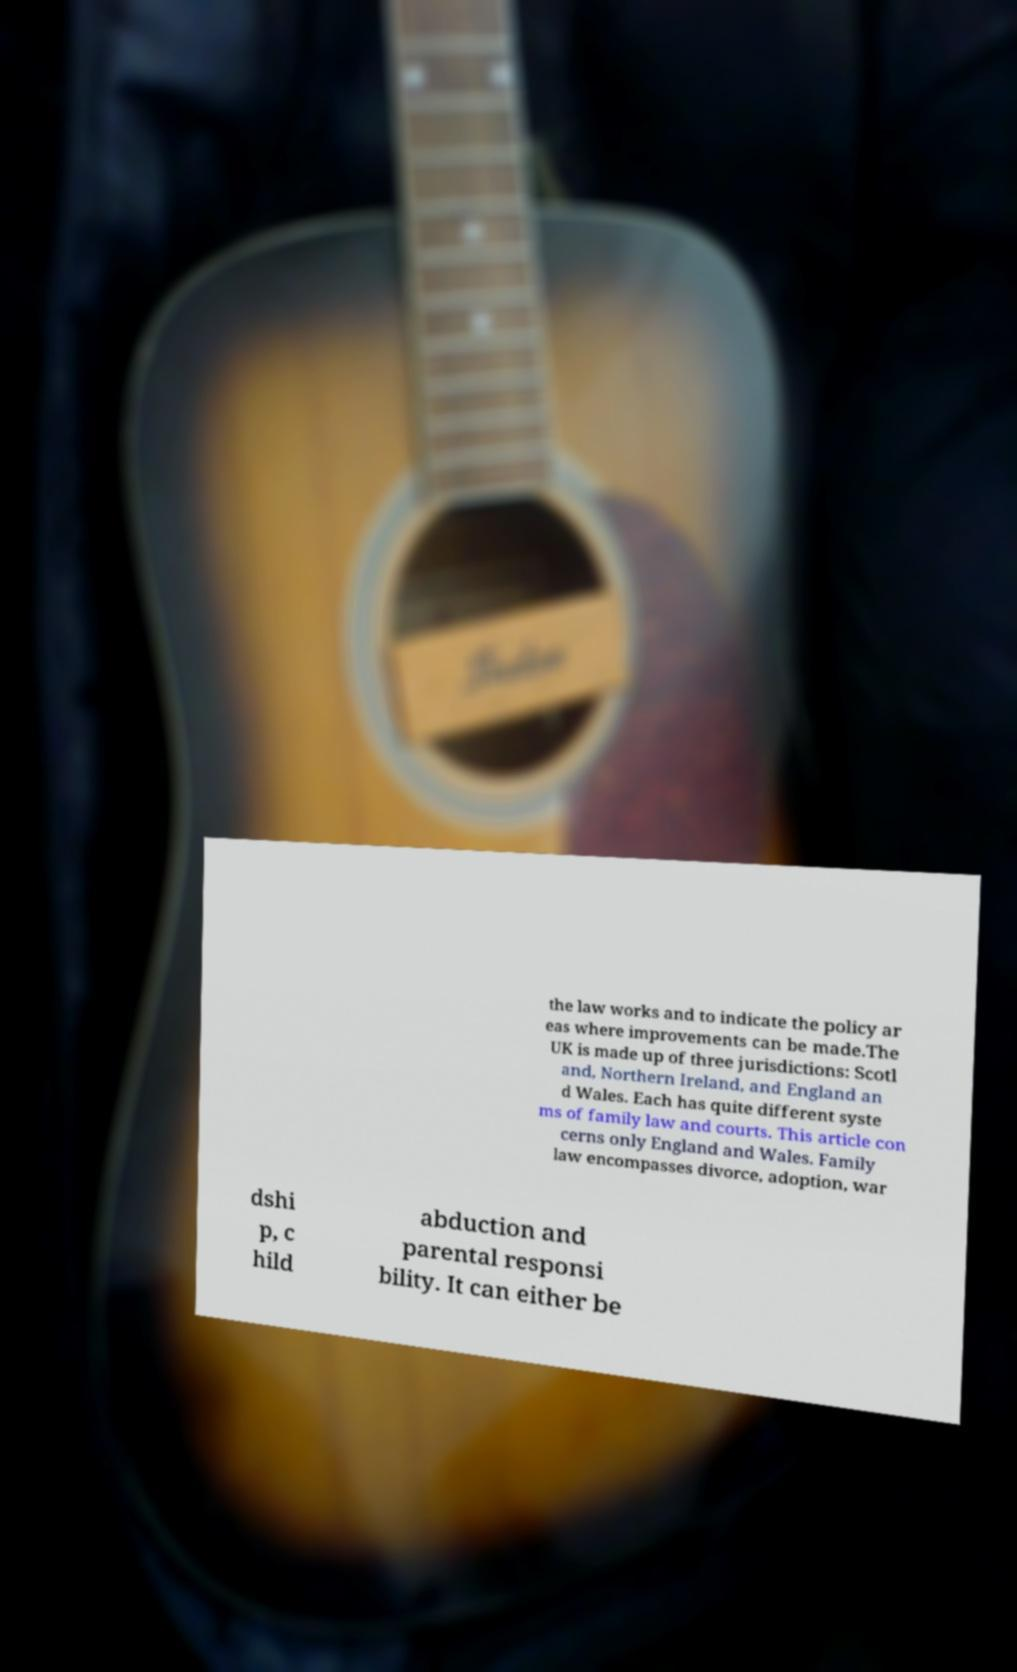I need the written content from this picture converted into text. Can you do that? the law works and to indicate the policy ar eas where improvements can be made.The UK is made up of three jurisdictions: Scotl and, Northern Ireland, and England an d Wales. Each has quite different syste ms of family law and courts. This article con cerns only England and Wales. Family law encompasses divorce, adoption, war dshi p, c hild abduction and parental responsi bility. It can either be 